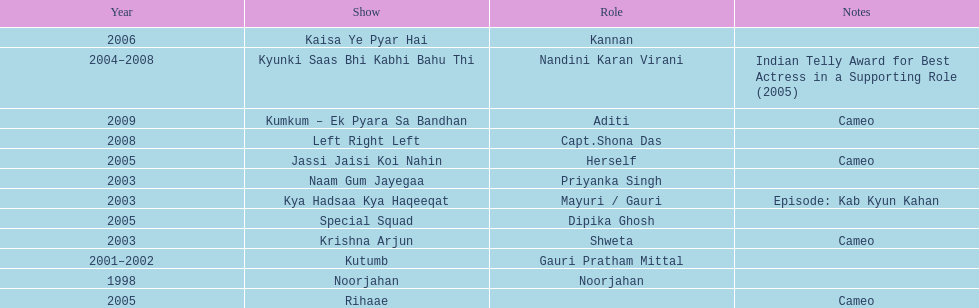Besides rihaae, in what other show did gauri tejwani cameo in 2005? Jassi Jaisi Koi Nahin. 